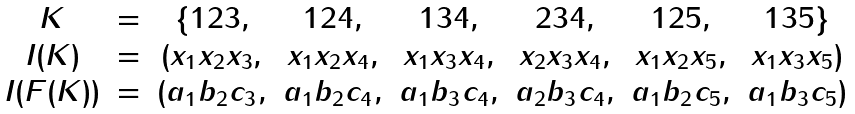<formula> <loc_0><loc_0><loc_500><loc_500>\begin{matrix} K & = & \{ 1 2 3 , & 1 2 4 , & 1 3 4 , & 2 3 4 , & 1 2 5 , & 1 3 5 \} \\ I ( K ) & = & ( x _ { 1 } x _ { 2 } x _ { 3 } , & x _ { 1 } x _ { 2 } x _ { 4 } , & x _ { 1 } x _ { 3 } x _ { 4 } , & x _ { 2 } x _ { 3 } x _ { 4 } , & x _ { 1 } x _ { 2 } x _ { 5 } , & x _ { 1 } x _ { 3 } x _ { 5 } ) \\ I ( F ( K ) ) & = & ( a _ { 1 } b _ { 2 } c _ { 3 } , & a _ { 1 } b _ { 2 } c _ { 4 } , & a _ { 1 } b _ { 3 } c _ { 4 } , & a _ { 2 } b _ { 3 } c _ { 4 } , & a _ { 1 } b _ { 2 } c _ { 5 } , & a _ { 1 } b _ { 3 } c _ { 5 } ) \\ \end{matrix}</formula> 